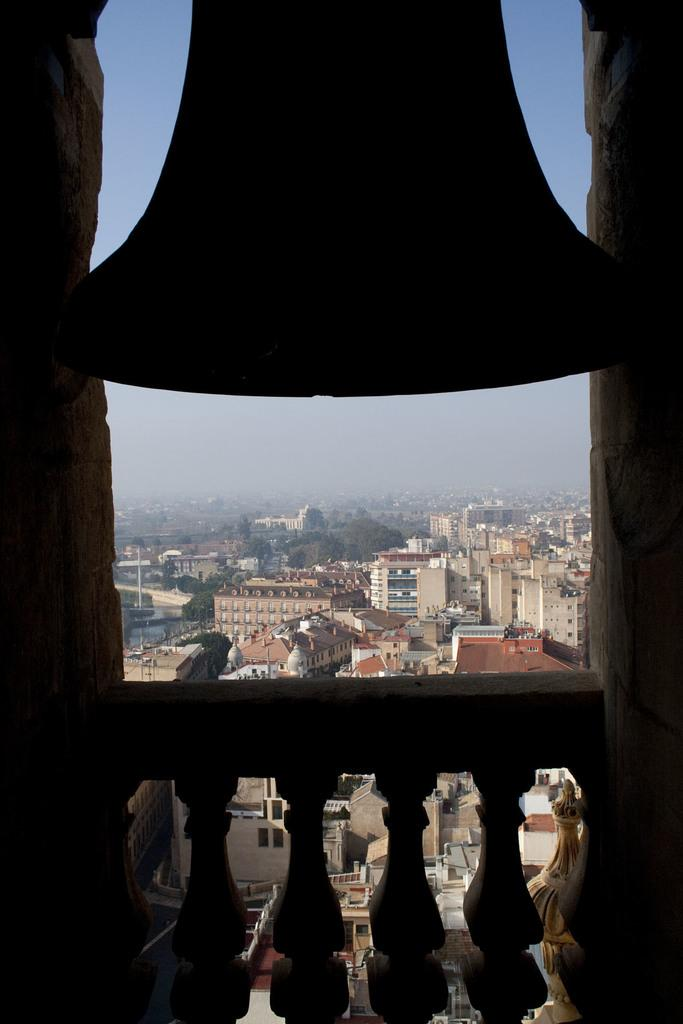What is located in the foreground of the image? There is a deck rail in the foreground of the image. What is hanging on the deck rail? A bell is hanging on the deck rail. What can be seen in the background of the image? The sky, trees, buildings, houses, and other objects are visible in the background of the image. How many waves can be seen crashing against the house in the image? There are no waves present in the image, as it features a deck rail, a bell, and various background elements, but no body of water or waves. 